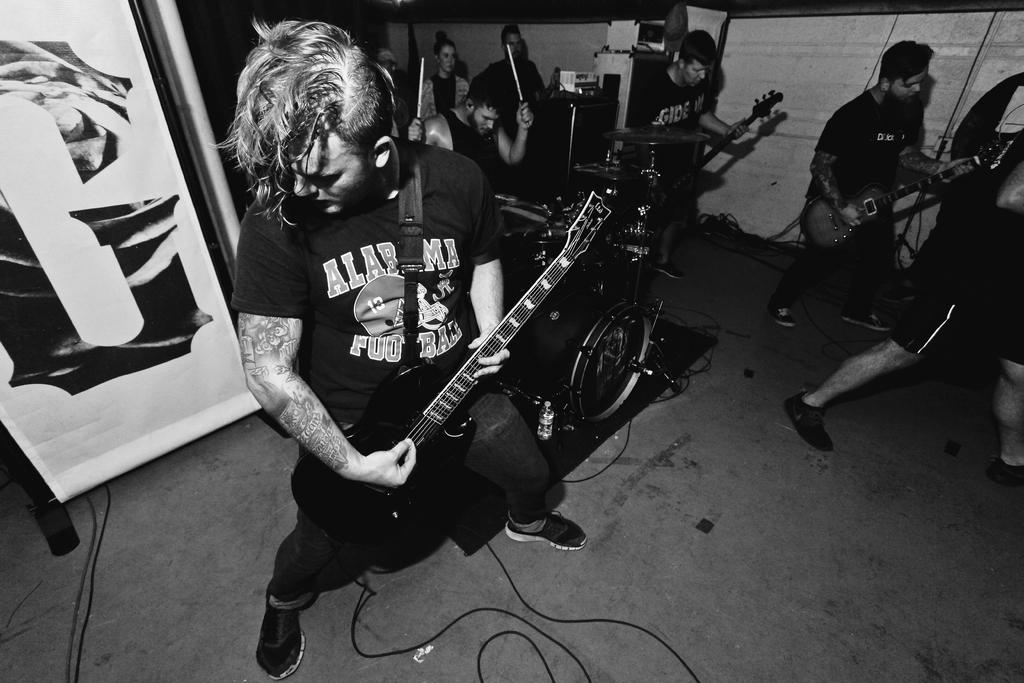What is the main activity of the people in the image? The main activity of the people in the image is playing musical instruments, as most of them are holding guitars. Can you describe the person sitting in the middle of the group? The person sitting in the middle of the group is playing drums. How many people are holding guitars in the image? Most of the people in the image are holding guitars, but we cannot determine the exact number without counting them. What type of riddle can be seen on the wall behind the group? There is no riddle visible on the wall behind the group in the image. Can you describe the animal that is playing the guitar in the image? There are no animals present in the image; all the people playing musical instruments are human. 